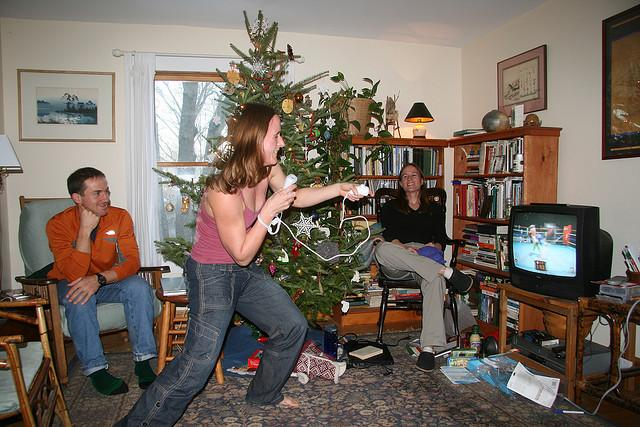What type of television display technology is being used in the living room? crt 